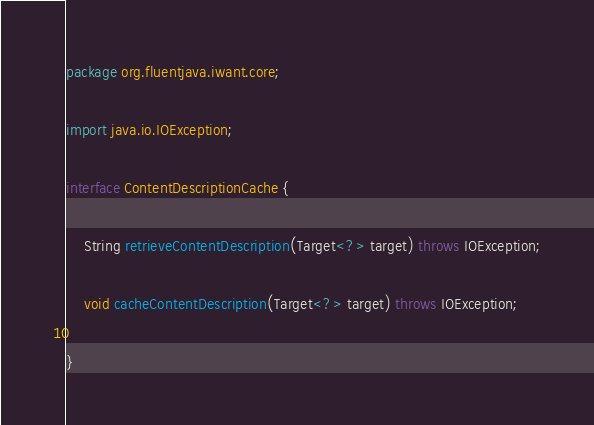Convert code to text. <code><loc_0><loc_0><loc_500><loc_500><_Java_>package org.fluentjava.iwant.core;

import java.io.IOException;

interface ContentDescriptionCache {

	String retrieveContentDescription(Target<?> target) throws IOException;

	void cacheContentDescription(Target<?> target) throws IOException;

}
</code> 